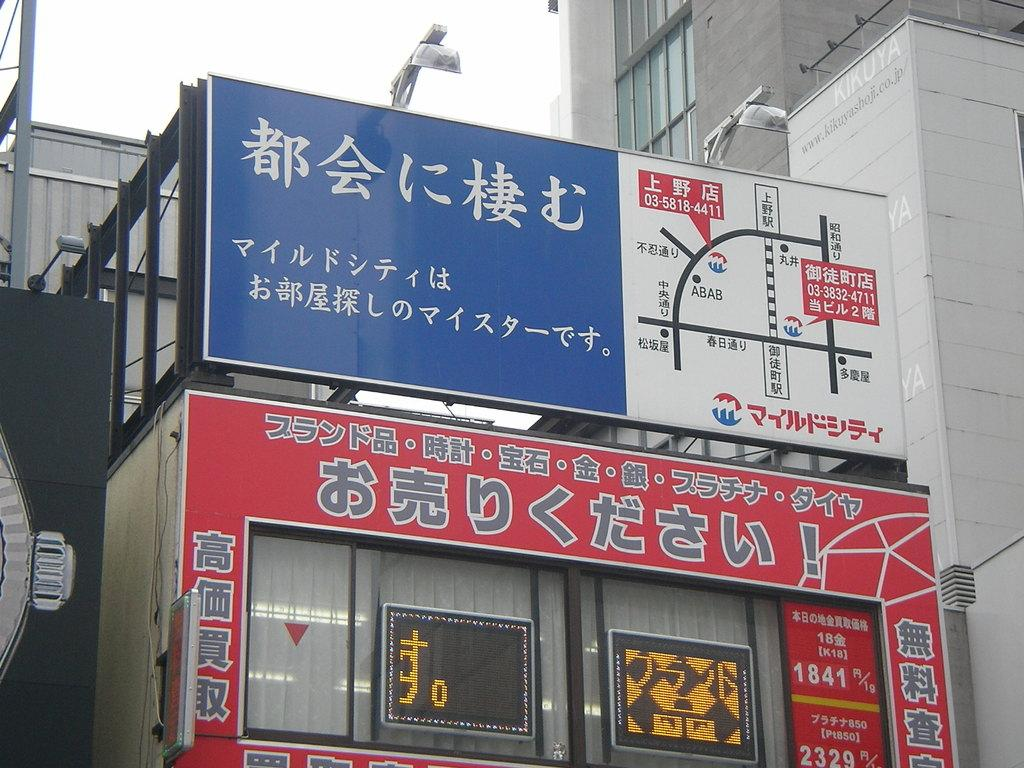What type of structures can be seen in the image? There are buildings in the image. What can be found on the buildings in the image? There are name boards on the buildings in the image. What else is visible in the image besides the buildings and name boards? There are lights and other objects in the image. What is visible in the background of the image? The sky is visible in the background of the image. Can you tell me how many crows are sitting on the basin in the image? There are no crows or basins present in the image. What type of jewel can be seen on the buildings in the image? There are no jewels visible on the buildings in the image. 